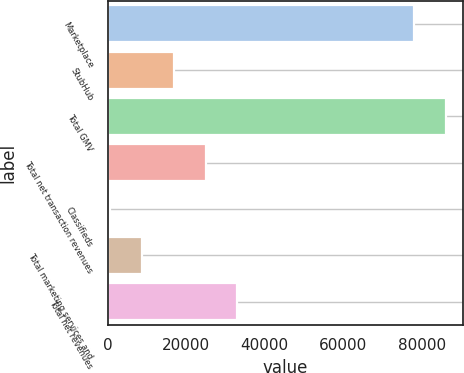<chart> <loc_0><loc_0><loc_500><loc_500><bar_chart><fcel>Marketplace<fcel>StubHub<fcel>Total GMV<fcel>Total net transaction revenues<fcel>Classifieds<fcel>Total marketing services and<fcel>Total net revenues<nl><fcel>78099<fcel>16897<fcel>86196<fcel>24994<fcel>703<fcel>8800<fcel>33091<nl></chart> 